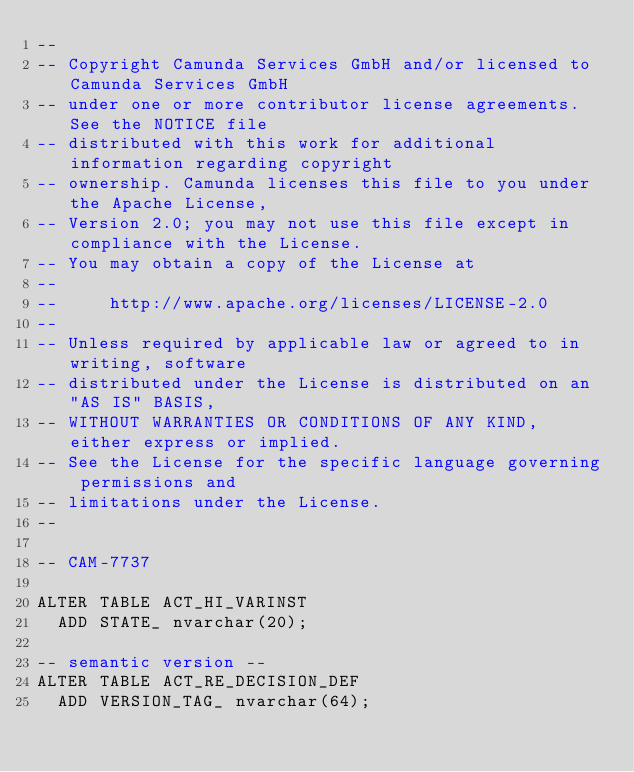Convert code to text. <code><loc_0><loc_0><loc_500><loc_500><_SQL_>--
-- Copyright Camunda Services GmbH and/or licensed to Camunda Services GmbH
-- under one or more contributor license agreements. See the NOTICE file
-- distributed with this work for additional information regarding copyright
-- ownership. Camunda licenses this file to you under the Apache License,
-- Version 2.0; you may not use this file except in compliance with the License.
-- You may obtain a copy of the License at
--
--     http://www.apache.org/licenses/LICENSE-2.0
--
-- Unless required by applicable law or agreed to in writing, software
-- distributed under the License is distributed on an "AS IS" BASIS,
-- WITHOUT WARRANTIES OR CONDITIONS OF ANY KIND, either express or implied.
-- See the License for the specific language governing permissions and
-- limitations under the License.
--

-- CAM-7737

ALTER TABLE ACT_HI_VARINST
  ADD STATE_ nvarchar(20);

-- semantic version --
ALTER TABLE ACT_RE_DECISION_DEF
  ADD VERSION_TAG_ nvarchar(64);
</code> 